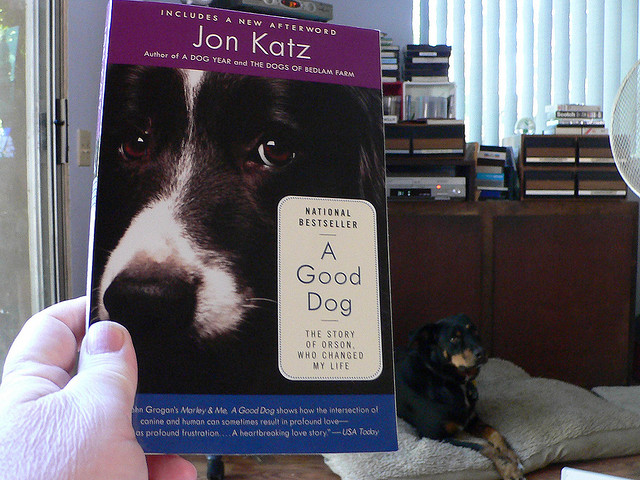<image>What breed of dog is in the photo? I don't know what breed of dog is in the photo. It can be seen as spaniel, rottweiler, lab or australian shepherd. What breed of dog is in the photo? I am not sure about the breed of the dog in the photo. It can be a spaniel, rottweiler, lab or australian shepherd. 